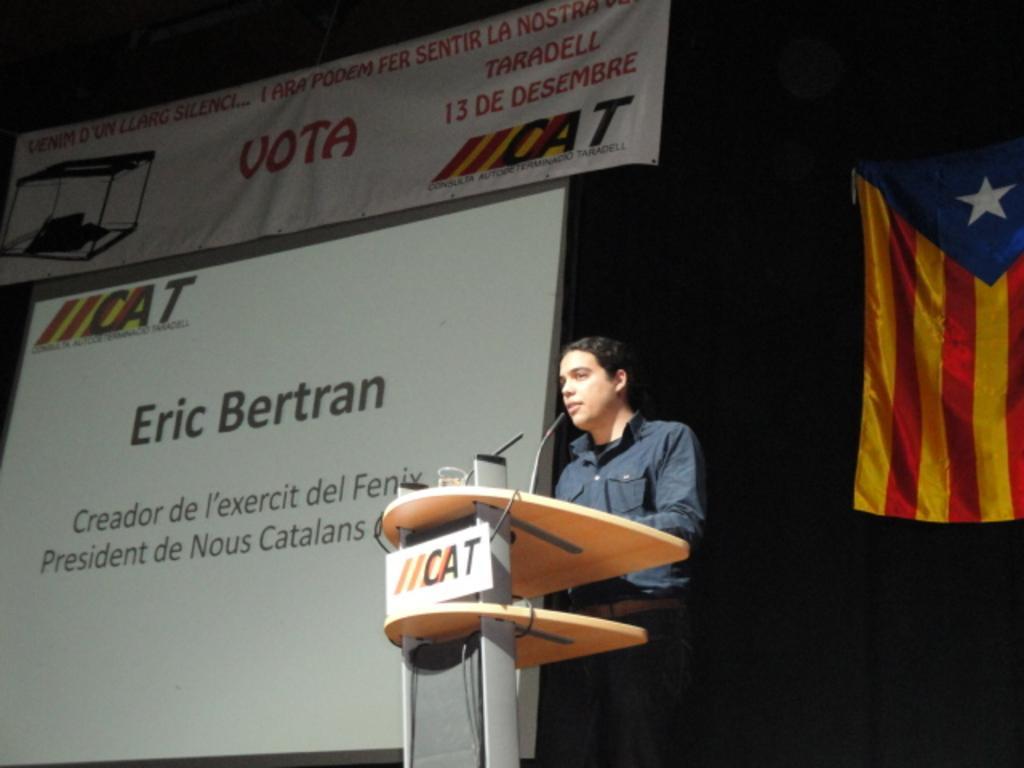Could you give a brief overview of what you see in this image? In this image we can see a man is standing, in front of him podium is there. He is wearing grey color shirt. Background of the image banner, screen and flag is present. 